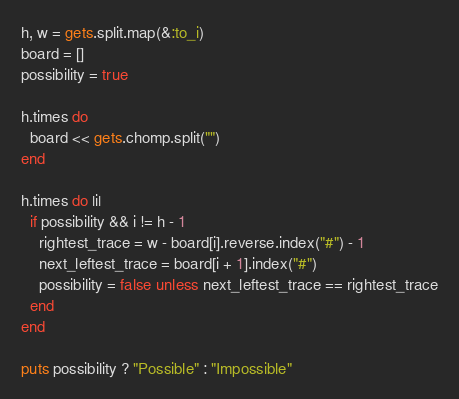Convert code to text. <code><loc_0><loc_0><loc_500><loc_500><_Ruby_>h, w = gets.split.map(&:to_i)
board = []
possibility = true

h.times do
  board << gets.chomp.split("")
end

h.times do |i|
  if possibility && i != h - 1
    rightest_trace = w - board[i].reverse.index("#") - 1
    next_leftest_trace = board[i + 1].index("#")
    possibility = false unless next_leftest_trace == rightest_trace
  end
end

puts possibility ? "Possible" : "Impossible"
</code> 